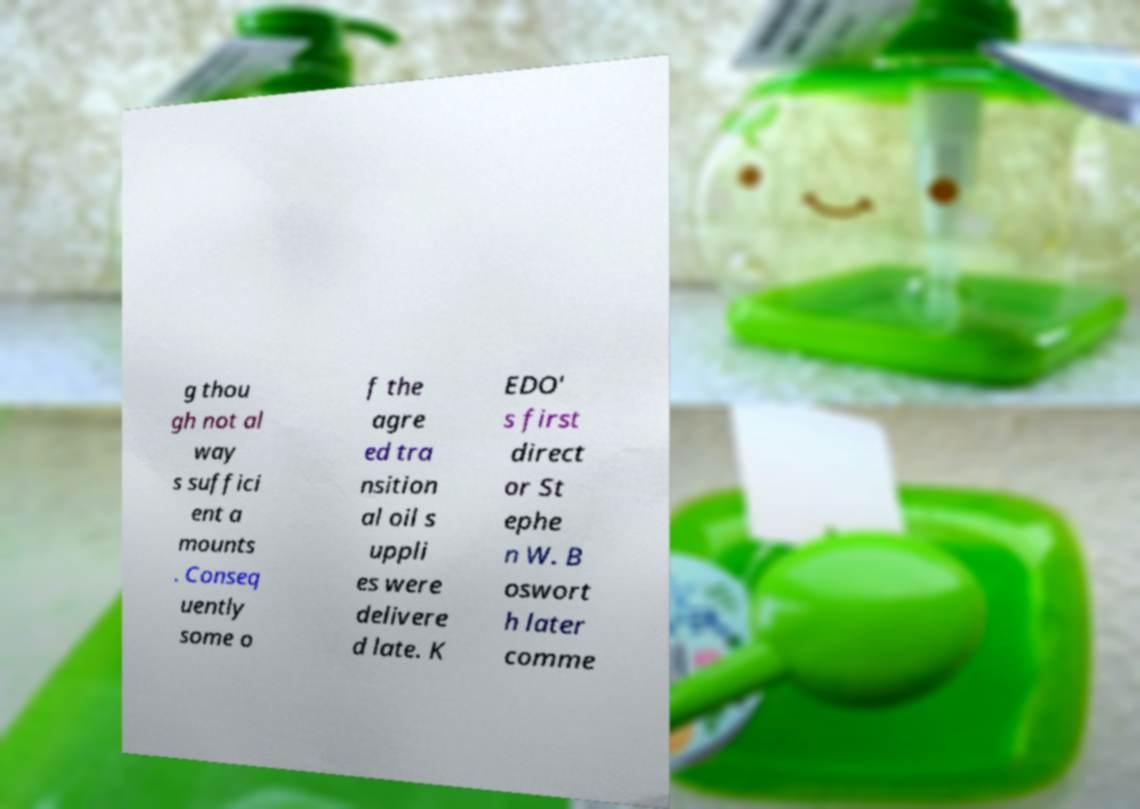Please identify and transcribe the text found in this image. g thou gh not al way s suffici ent a mounts . Conseq uently some o f the agre ed tra nsition al oil s uppli es were delivere d late. K EDO' s first direct or St ephe n W. B oswort h later comme 